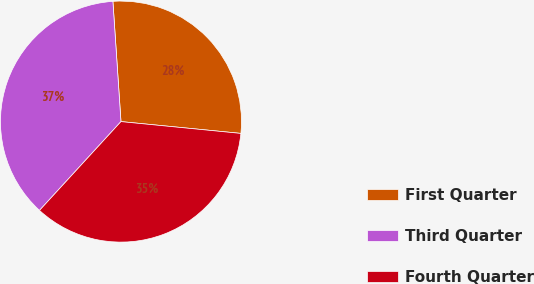Convert chart to OTSL. <chart><loc_0><loc_0><loc_500><loc_500><pie_chart><fcel>First Quarter<fcel>Third Quarter<fcel>Fourth Quarter<nl><fcel>27.63%<fcel>37.12%<fcel>35.25%<nl></chart> 